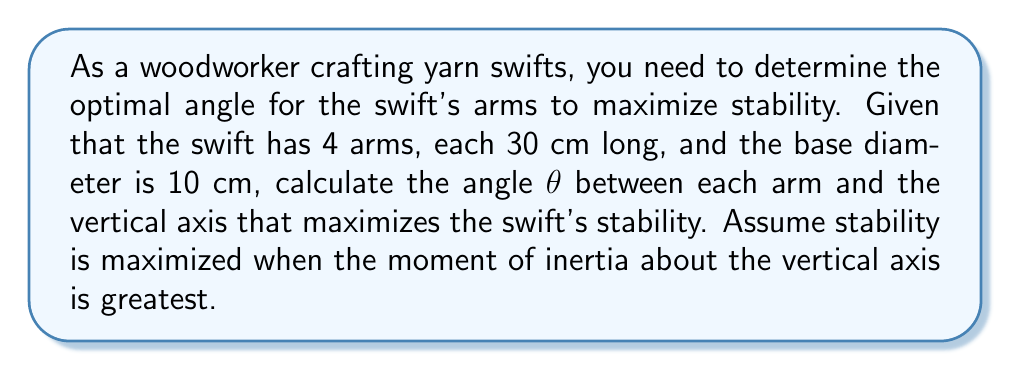Can you solve this math problem? To solve this problem, we'll follow these steps:

1) The moment of inertia (I) for a single arm about the vertical axis is given by:

   $$I = \frac{1}{3}mL^2\sin^2\theta$$

   where m is the mass of the arm, L is the length of the arm, and θ is the angle from vertical.

2) For maximum stability, we want to maximize the total moment of inertia. Since there are 4 identical arms, we can multiply the above equation by 4:

   $$I_{total} = \frac{4}{3}mL^2\sin^2\theta$$

3) To find the maximum, we differentiate with respect to θ and set it to zero:

   $$\frac{dI_{total}}{d\theta} = \frac{8}{3}mL^2\sin\theta\cos\theta = 0$$

4) This equation is satisfied when either sin θ = 0 or cos θ = 0. sin θ = 0 gives θ = 0°, which would make the arms vertical and unstable. Therefore, we want cos θ = 0.

5) cos θ = 0 when θ = 90°. However, this isn't possible given the constraints of our problem. The base diameter limits how far the arms can spread.

6) To find the maximum possible angle, we can use the Pythagorean theorem:

   $$(30\sin\theta)^2 + (30\cos\theta)^2 = 30^2$$
   $$5^2 + (30\cos\theta)^2 = 30^2$$

7) Solving this equation:

   $$30\cos\theta = \sqrt{30^2 - 5^2} = \sqrt{875} \approx 29.58$$
   $$\cos\theta \approx 0.986$$
   $$\theta \approx \arccos(0.986) \approx 9.46°$$

Therefore, the optimal angle for maximum stability, given the constraints, is approximately 9.46°.
Answer: $9.46°$ 